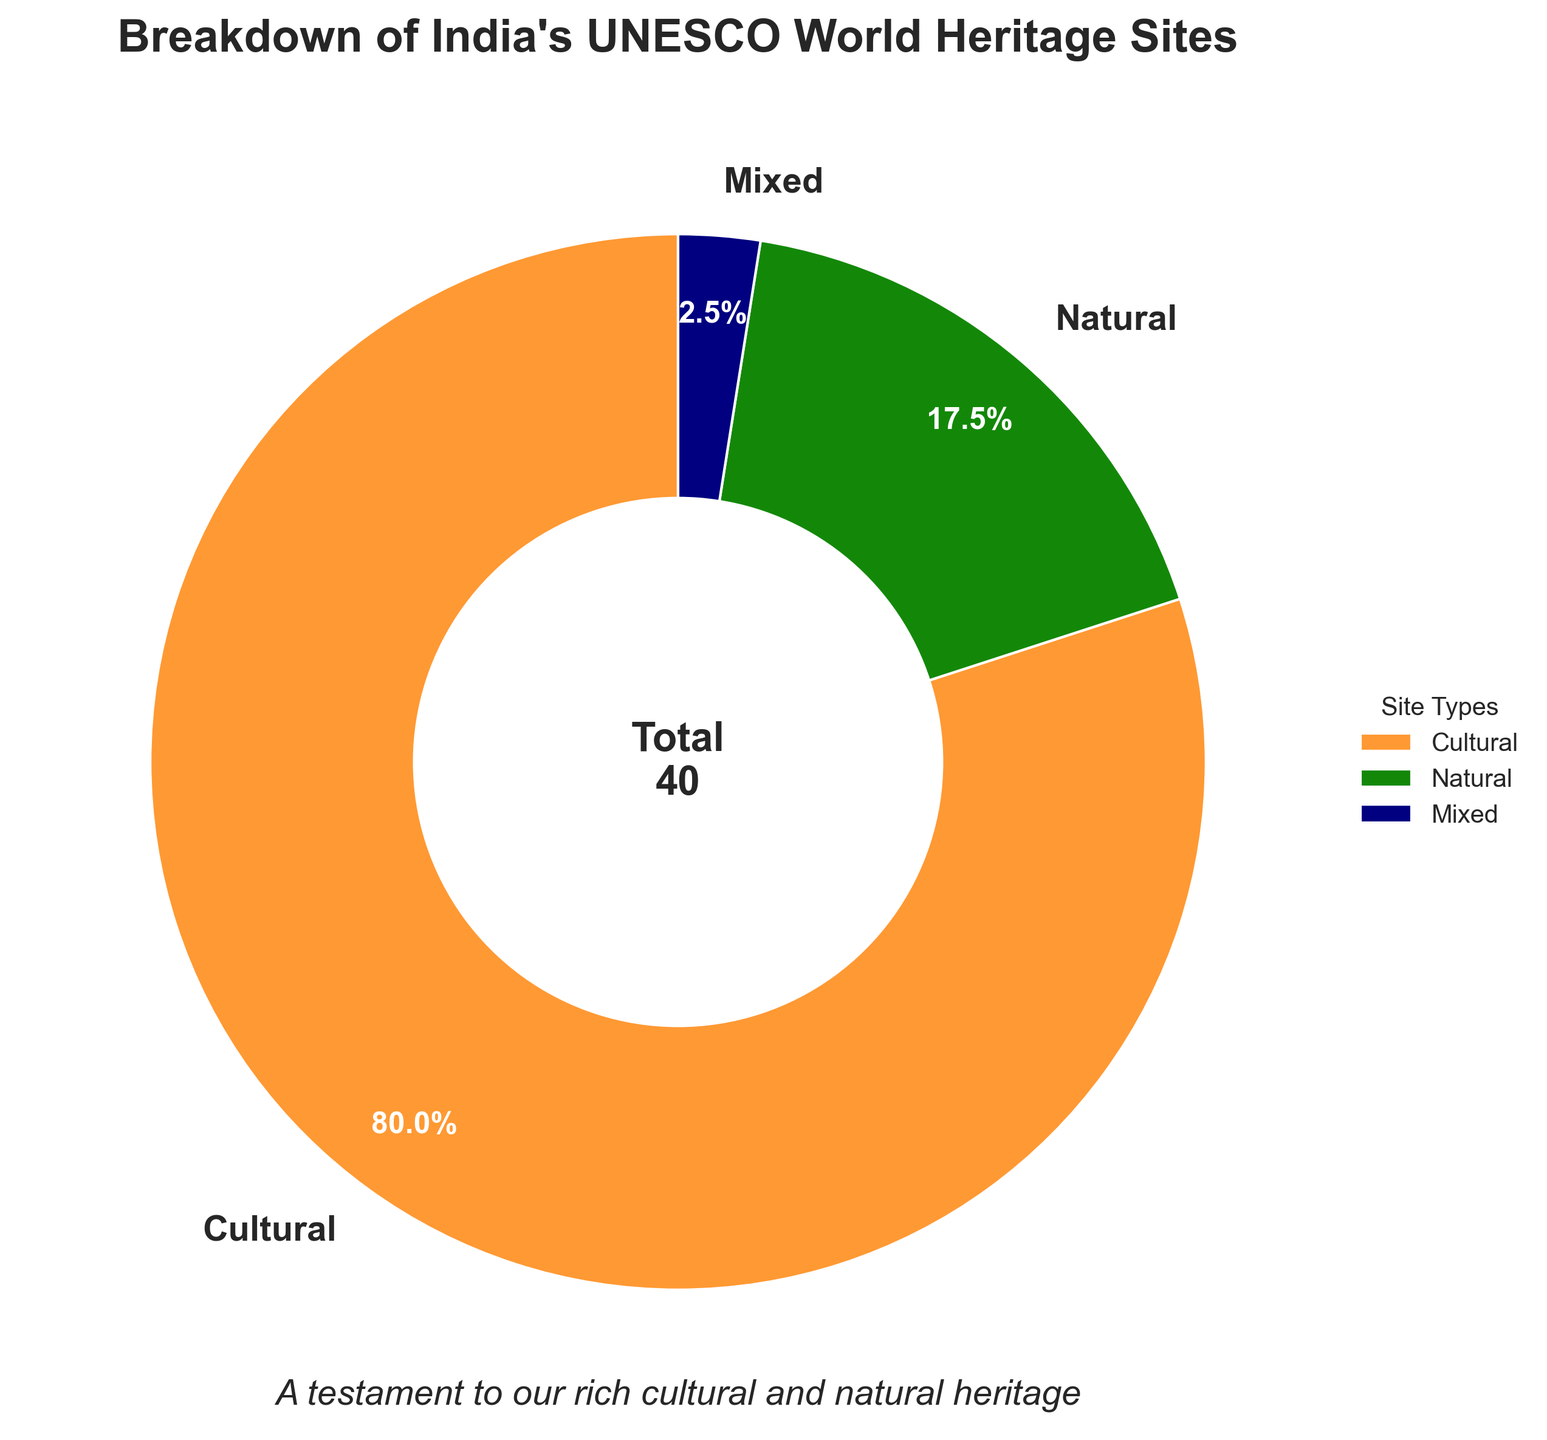What percentage of India's UNESCO World Heritage Sites are Cultural? To determine the percentage of Cultural sites, look at the pie chart section labeled "Cultural" and read the percentage directly from the chart.
Answer: 81.6% Which type of site has the smallest representation? Identify the smallest section of the pie chart, which represents the type with the fewest sites. The smallest segment in the pie chart is labeled "Mixed."
Answer: Mixed How many more Cultural sites are there than Natural sites? First, note the number of Cultural sites (32) and Natural sites (7) from the chart. Then, subtract the number of Natural sites from the number of Cultural sites: 32 - 7 = 25.
Answer: 25 What proportion of the total sites are Natural and Mixed combined? Add the number of Natural sites (7) and Mixed sites (1) to get 8. Then, divide by the total number of sites (40): 8 / 40 = 0.2 or 20%.
Answer: 20% If you were to combine Cultural and Natural sites, what fraction of the total would they represent? Add the number of Cultural sites (32) and Natural sites (7) to get 39. The total number of sites is 40, so the fraction is 39 / 40.
Answer: 39/40 How many times more Cultural sites are there compared to Mixed sites? Divide the number of Cultural sites (32) by the number of Mixed sites (1): 32 / 1 = 32.
Answer: 32 Which sections of the pie chart use the Indian flag colors and what are they? Identify the colors used in the pie chart that correspond to the Indian flag: saffron for Cultural, green for Natural, and navy blue for Mixed.
Answer: Cultural, Natural, Mixed What does the subtitle of the pie chart convey about the significance of India's heritage sites? Read the subtitle below the main title, "A testament to our rich cultural and natural heritage," which emphasizes the importance of these heritage sites.
Answer: It highlights the richness of India's cultural and natural heritage Where on the chart is the total number of sites displayed? Look at the center of the pie chart where the total number of sites is indicated with the text "Total 40."
Answer: In the center of the chart 